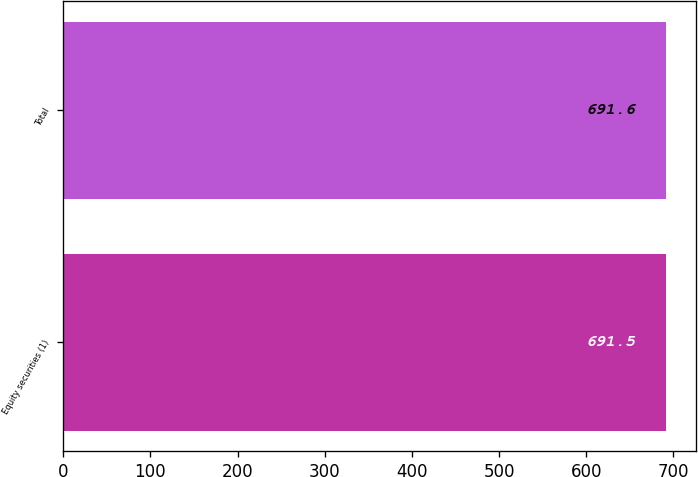<chart> <loc_0><loc_0><loc_500><loc_500><bar_chart><fcel>Equity securities (1)<fcel>Total<nl><fcel>691.5<fcel>691.6<nl></chart> 